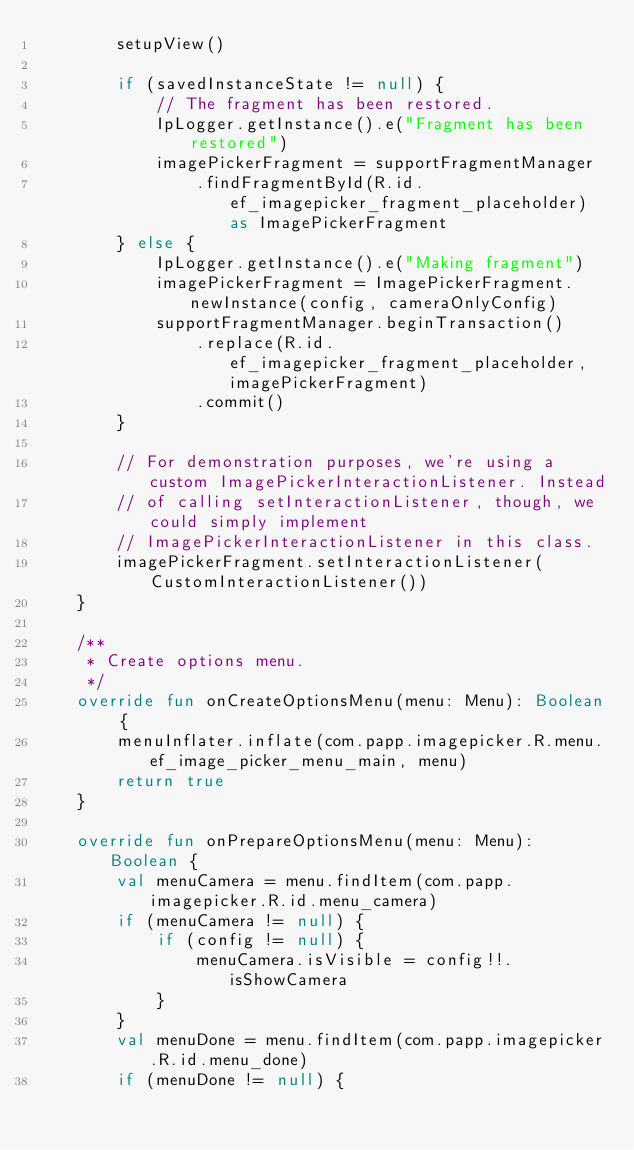Convert code to text. <code><loc_0><loc_0><loc_500><loc_500><_Kotlin_>        setupView()

        if (savedInstanceState != null) {
            // The fragment has been restored.
            IpLogger.getInstance().e("Fragment has been restored")
            imagePickerFragment = supportFragmentManager
                .findFragmentById(R.id.ef_imagepicker_fragment_placeholder) as ImagePickerFragment
        } else {
            IpLogger.getInstance().e("Making fragment")
            imagePickerFragment = ImagePickerFragment.newInstance(config, cameraOnlyConfig)
            supportFragmentManager.beginTransaction()
                .replace(R.id.ef_imagepicker_fragment_placeholder, imagePickerFragment)
                .commit()
        }

        // For demonstration purposes, we're using a custom ImagePickerInteractionListener. Instead
        // of calling setInteractionListener, though, we could simply implement
        // ImagePickerInteractionListener in this class.
        imagePickerFragment.setInteractionListener(CustomInteractionListener())
    }

    /**
     * Create options menu.
     */
    override fun onCreateOptionsMenu(menu: Menu): Boolean {
        menuInflater.inflate(com.papp.imagepicker.R.menu.ef_image_picker_menu_main, menu)
        return true
    }

    override fun onPrepareOptionsMenu(menu: Menu): Boolean {
        val menuCamera = menu.findItem(com.papp.imagepicker.R.id.menu_camera)
        if (menuCamera != null) {
            if (config != null) {
                menuCamera.isVisible = config!!.isShowCamera
            }
        }
        val menuDone = menu.findItem(com.papp.imagepicker.R.id.menu_done)
        if (menuDone != null) {</code> 